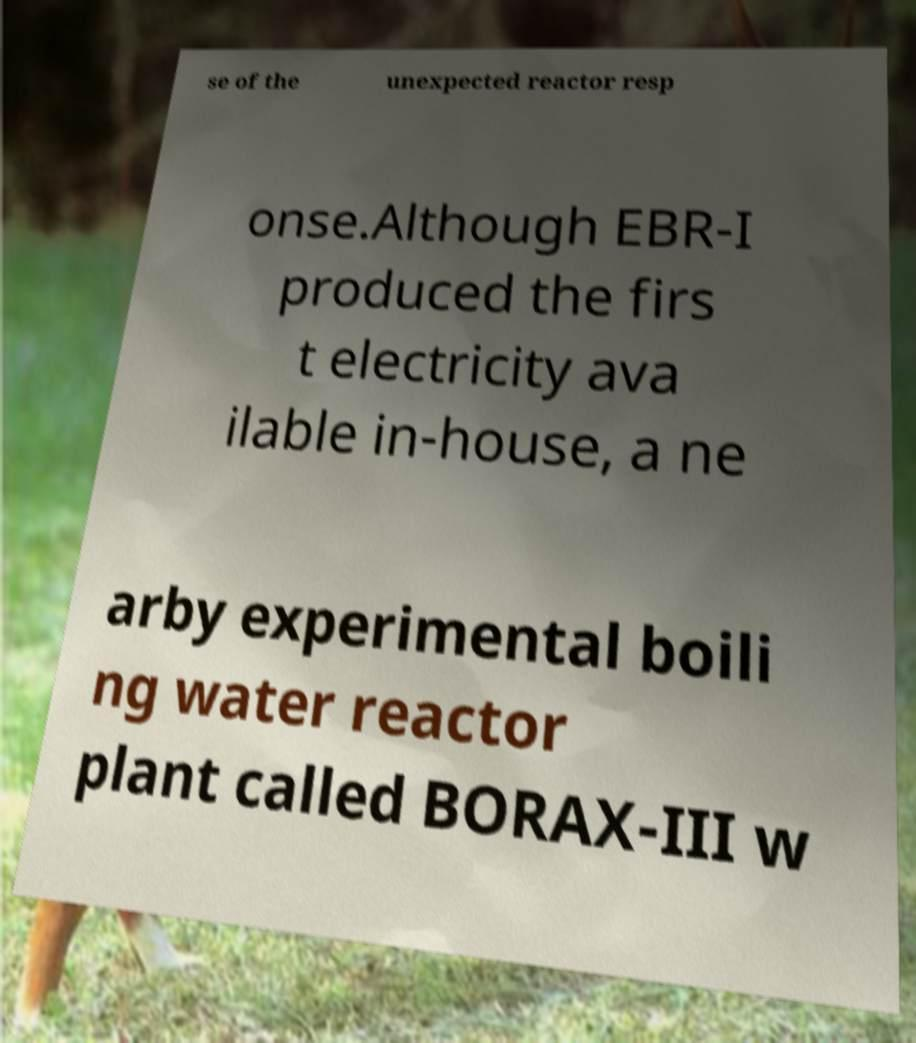For documentation purposes, I need the text within this image transcribed. Could you provide that? se of the unexpected reactor resp onse.Although EBR-I produced the firs t electricity ava ilable in-house, a ne arby experimental boili ng water reactor plant called BORAX-III w 